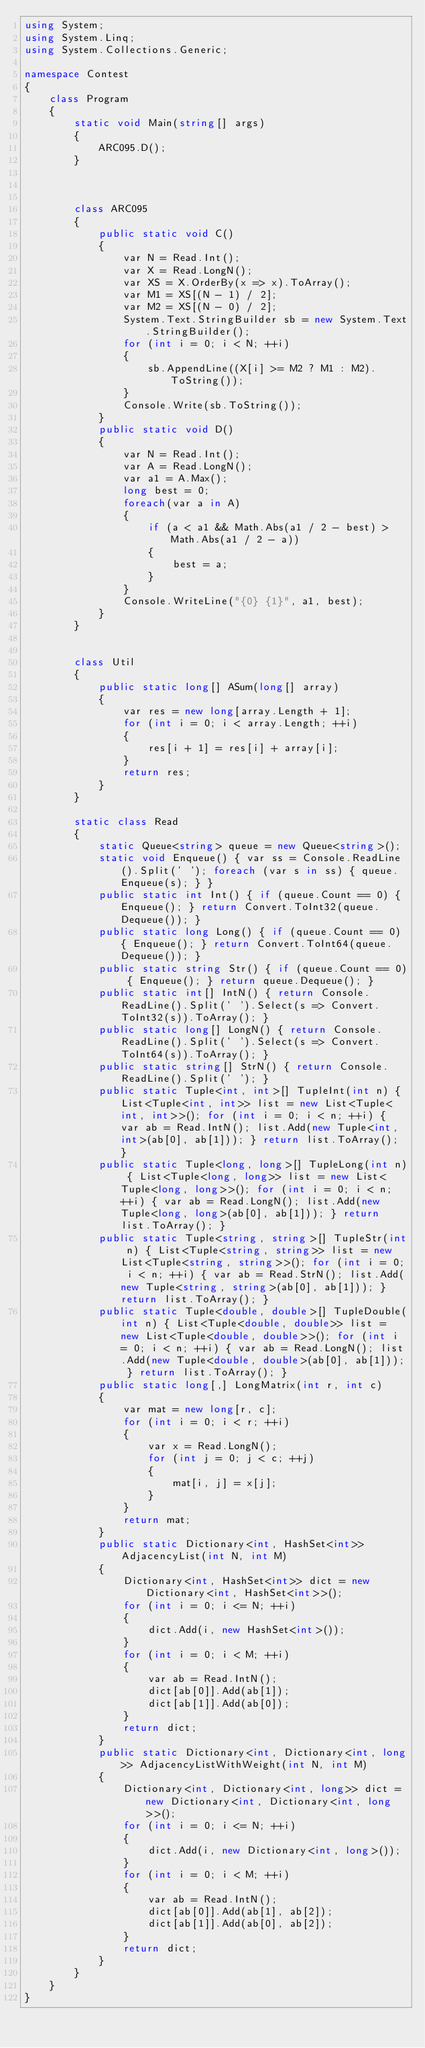Convert code to text. <code><loc_0><loc_0><loc_500><loc_500><_C#_>using System;
using System.Linq;
using System.Collections.Generic;

namespace Contest
{
    class Program
    {
        static void Main(string[] args)
        {
            ARC095.D();
        }



        class ARC095
        {
            public static void C()
            {
                var N = Read.Int();
                var X = Read.LongN();
                var XS = X.OrderBy(x => x).ToArray();
                var M1 = XS[(N - 1) / 2];
                var M2 = XS[(N - 0) / 2];
                System.Text.StringBuilder sb = new System.Text.StringBuilder();
                for (int i = 0; i < N; ++i)
                {
                    sb.AppendLine((X[i] >= M2 ? M1 : M2).ToString());
                }
                Console.Write(sb.ToString());
            }
            public static void D()
            {
                var N = Read.Int();
                var A = Read.LongN();
                var a1 = A.Max();
                long best = 0;
                foreach(var a in A)
                {
                    if (a < a1 && Math.Abs(a1 / 2 - best) > Math.Abs(a1 / 2 - a))
                    {
                        best = a;
                    }
                }
                Console.WriteLine("{0} {1}", a1, best);
            }
        }


        class Util
        {
            public static long[] ASum(long[] array)
            {
                var res = new long[array.Length + 1];
                for (int i = 0; i < array.Length; ++i)
                {
                    res[i + 1] = res[i] + array[i];
                }
                return res;
            }
        }

        static class Read
        {
            static Queue<string> queue = new Queue<string>();
            static void Enqueue() { var ss = Console.ReadLine().Split(' '); foreach (var s in ss) { queue.Enqueue(s); } }
            public static int Int() { if (queue.Count == 0) { Enqueue(); } return Convert.ToInt32(queue.Dequeue()); }
            public static long Long() { if (queue.Count == 0) { Enqueue(); } return Convert.ToInt64(queue.Dequeue()); }
            public static string Str() { if (queue.Count == 0) { Enqueue(); } return queue.Dequeue(); }
            public static int[] IntN() { return Console.ReadLine().Split(' ').Select(s => Convert.ToInt32(s)).ToArray(); }
            public static long[] LongN() { return Console.ReadLine().Split(' ').Select(s => Convert.ToInt64(s)).ToArray(); }
            public static string[] StrN() { return Console.ReadLine().Split(' '); }
            public static Tuple<int, int>[] TupleInt(int n) { List<Tuple<int, int>> list = new List<Tuple<int, int>>(); for (int i = 0; i < n; ++i) { var ab = Read.IntN(); list.Add(new Tuple<int, int>(ab[0], ab[1])); } return list.ToArray(); }
            public static Tuple<long, long>[] TupleLong(int n) { List<Tuple<long, long>> list = new List<Tuple<long, long>>(); for (int i = 0; i < n; ++i) { var ab = Read.LongN(); list.Add(new Tuple<long, long>(ab[0], ab[1])); } return list.ToArray(); }
            public static Tuple<string, string>[] TupleStr(int n) { List<Tuple<string, string>> list = new List<Tuple<string, string>>(); for (int i = 0; i < n; ++i) { var ab = Read.StrN(); list.Add(new Tuple<string, string>(ab[0], ab[1])); } return list.ToArray(); }
            public static Tuple<double, double>[] TupleDouble(int n) { List<Tuple<double, double>> list = new List<Tuple<double, double>>(); for (int i = 0; i < n; ++i) { var ab = Read.LongN(); list.Add(new Tuple<double, double>(ab[0], ab[1])); } return list.ToArray(); }
            public static long[,] LongMatrix(int r, int c)
            {
                var mat = new long[r, c];
                for (int i = 0; i < r; ++i)
                {
                    var x = Read.LongN();
                    for (int j = 0; j < c; ++j)
                    {
                        mat[i, j] = x[j];
                    }
                }
                return mat;
            }
            public static Dictionary<int, HashSet<int>> AdjacencyList(int N, int M)
            {
                Dictionary<int, HashSet<int>> dict = new Dictionary<int, HashSet<int>>();
                for (int i = 0; i <= N; ++i)
                {
                    dict.Add(i, new HashSet<int>());
                }
                for (int i = 0; i < M; ++i)
                {
                    var ab = Read.IntN();
                    dict[ab[0]].Add(ab[1]);
                    dict[ab[1]].Add(ab[0]);
                }
                return dict;
            }
            public static Dictionary<int, Dictionary<int, long>> AdjacencyListWithWeight(int N, int M)
            {
                Dictionary<int, Dictionary<int, long>> dict = new Dictionary<int, Dictionary<int, long>>();
                for (int i = 0; i <= N; ++i)
                {
                    dict.Add(i, new Dictionary<int, long>());
                }
                for (int i = 0; i < M; ++i)
                {
                    var ab = Read.IntN();
                    dict[ab[0]].Add(ab[1], ab[2]);
                    dict[ab[1]].Add(ab[0], ab[2]);
                }
                return dict;
            }
        }
    }
}
</code> 